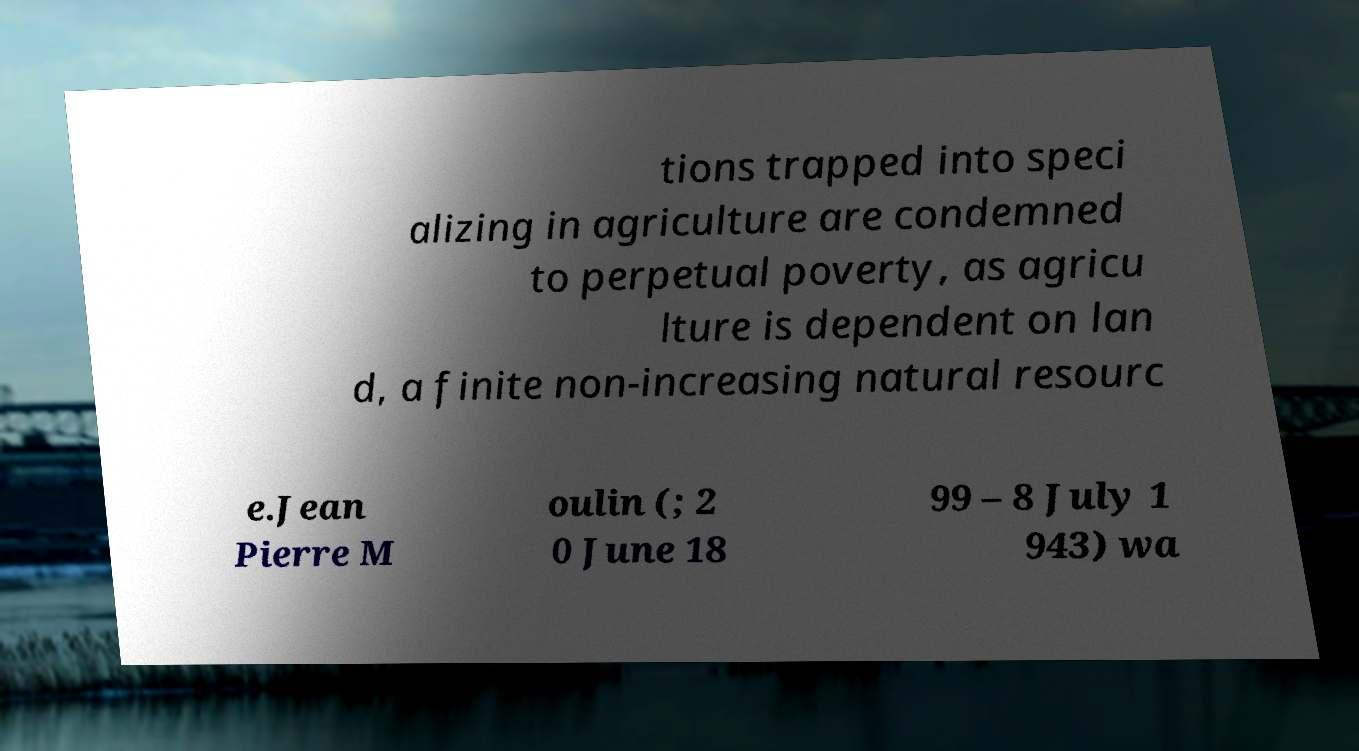For documentation purposes, I need the text within this image transcribed. Could you provide that? tions trapped into speci alizing in agriculture are condemned to perpetual poverty, as agricu lture is dependent on lan d, a finite non-increasing natural resourc e.Jean Pierre M oulin (; 2 0 June 18 99 – 8 July 1 943) wa 